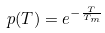Convert formula to latex. <formula><loc_0><loc_0><loc_500><loc_500>p ( T ) = e ^ { - \frac { T } { T _ { m } } }</formula> 